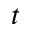<formula> <loc_0><loc_0><loc_500><loc_500>t</formula> 